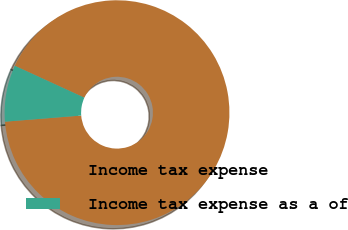Convert chart. <chart><loc_0><loc_0><loc_500><loc_500><pie_chart><fcel>Income tax expense<fcel>Income tax expense as a of<nl><fcel>91.88%<fcel>8.12%<nl></chart> 